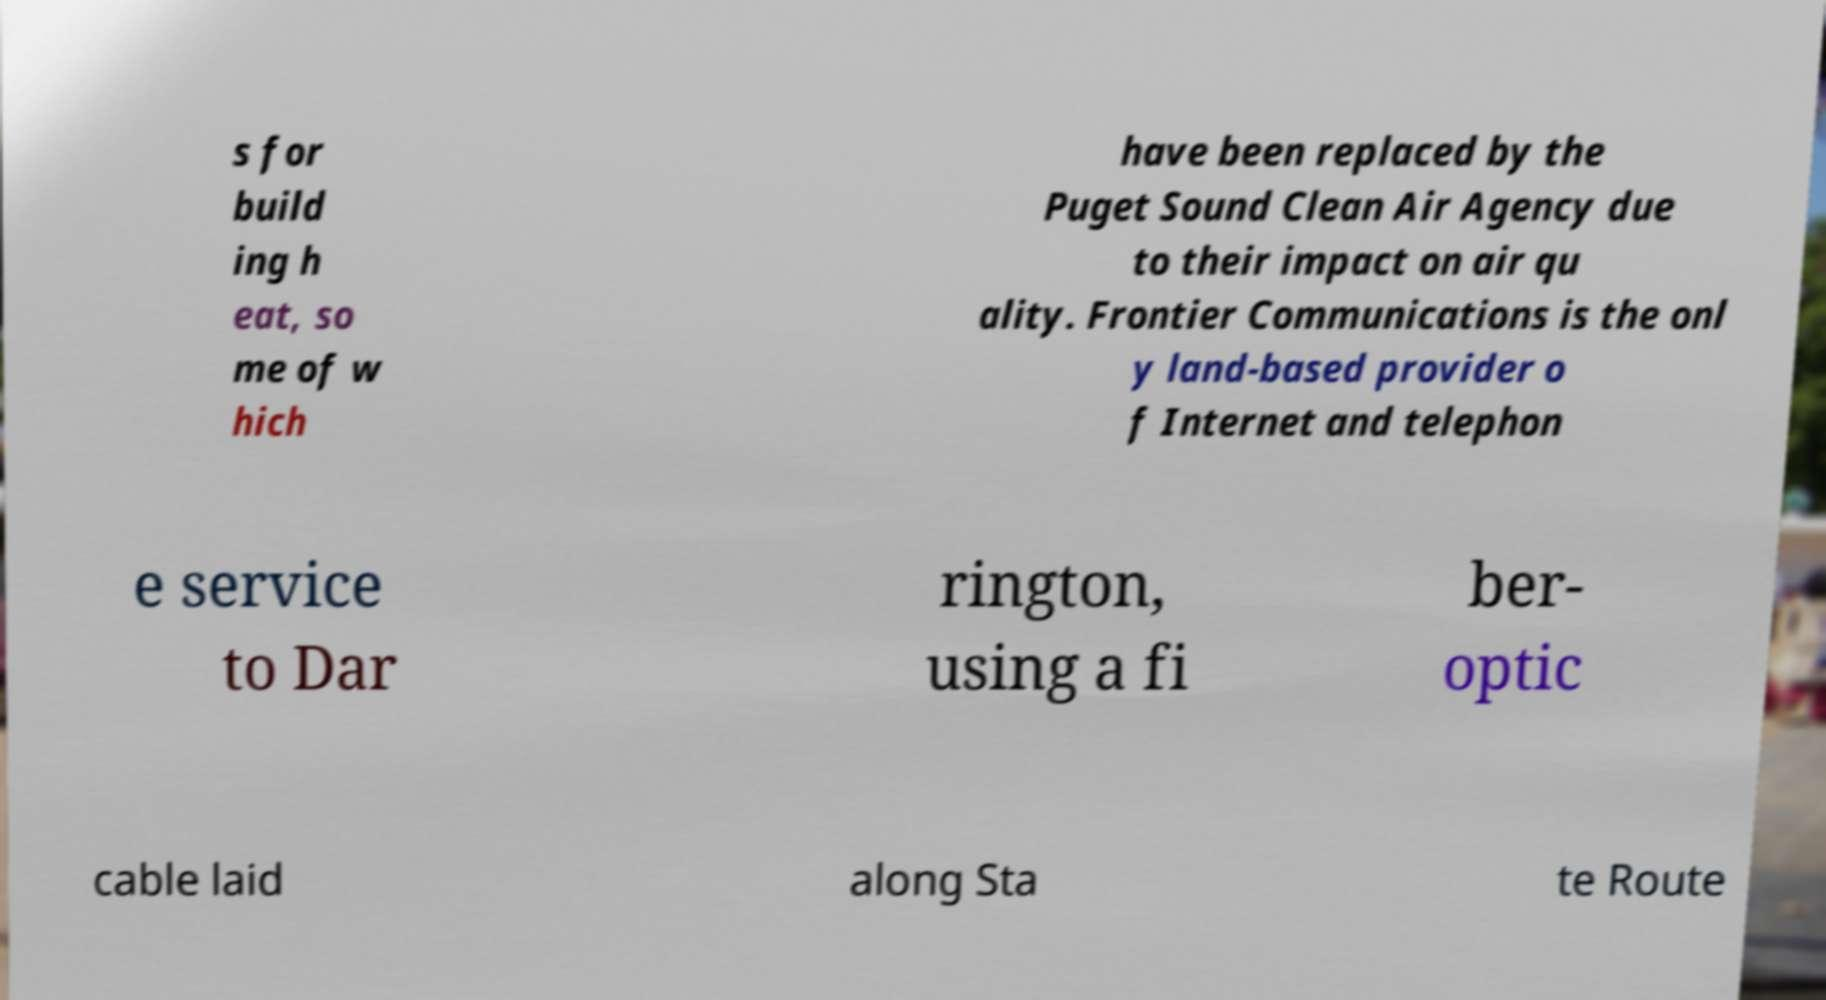Can you read and provide the text displayed in the image?This photo seems to have some interesting text. Can you extract and type it out for me? s for build ing h eat, so me of w hich have been replaced by the Puget Sound Clean Air Agency due to their impact on air qu ality. Frontier Communications is the onl y land-based provider o f Internet and telephon e service to Dar rington, using a fi ber- optic cable laid along Sta te Route 